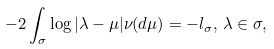<formula> <loc_0><loc_0><loc_500><loc_500>- 2 \int _ { \sigma } \log | \lambda - \mu | \nu ( d \mu ) = - l _ { \sigma } , \, \lambda \in \sigma ,</formula> 